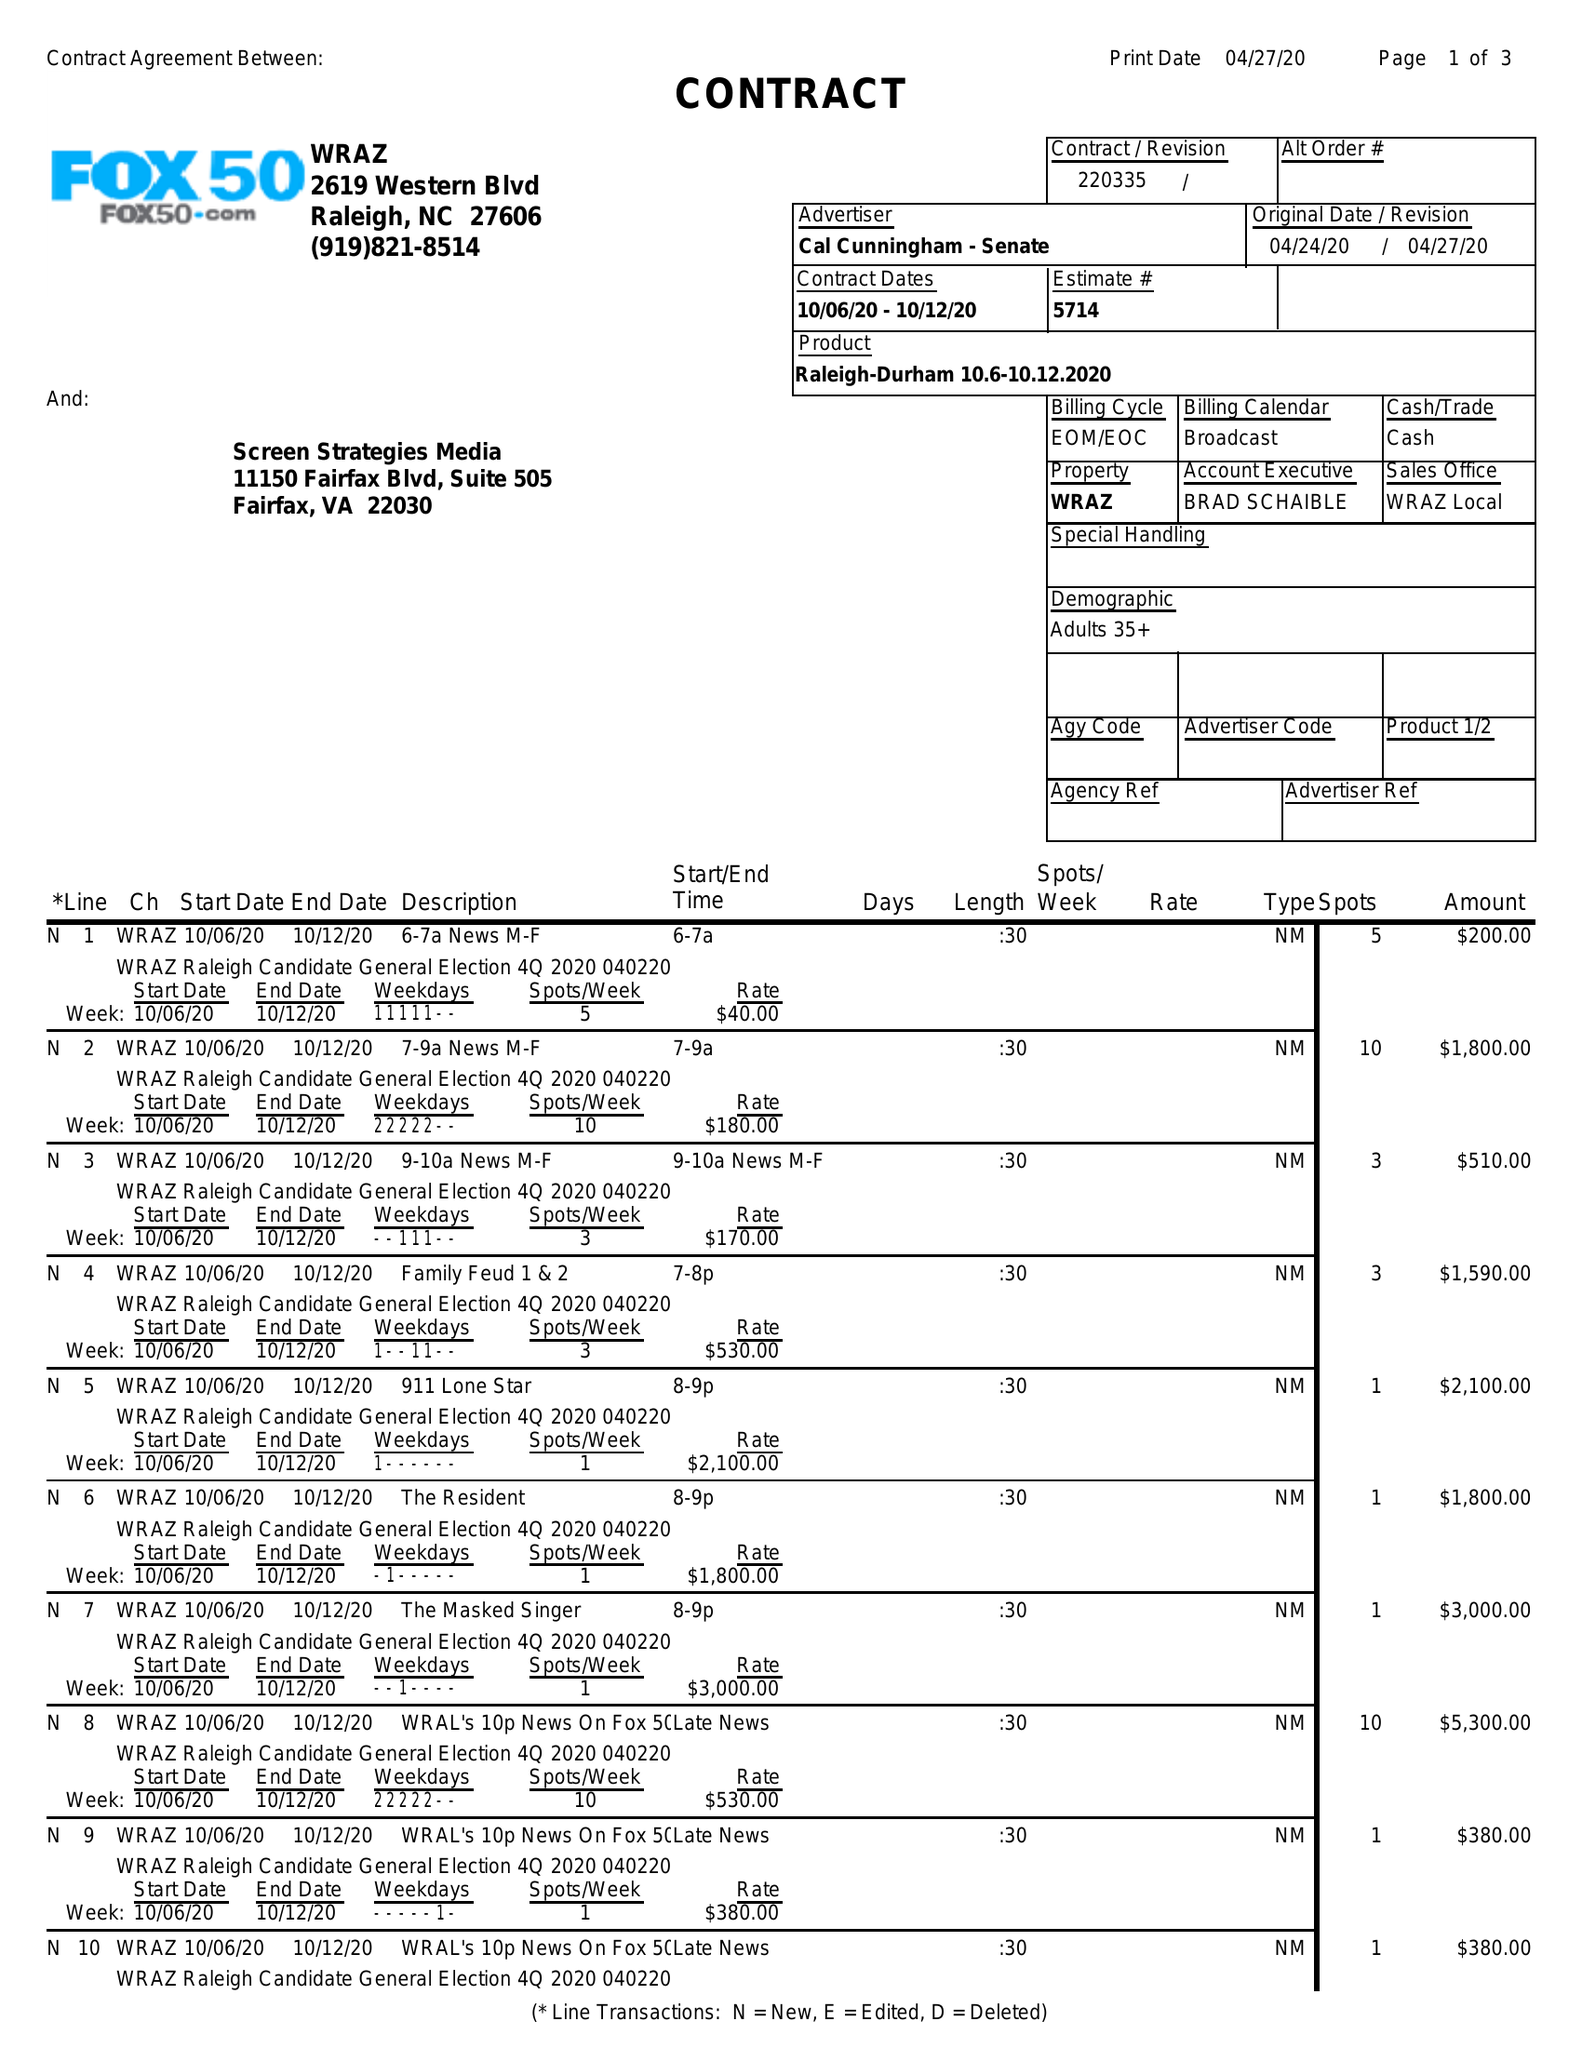What is the value for the flight_from?
Answer the question using a single word or phrase. 10/06/20 